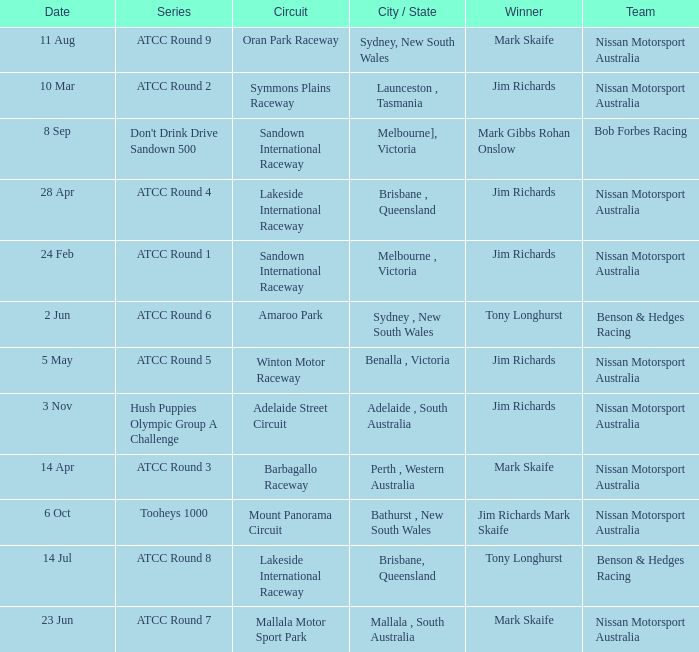Parse the full table. {'header': ['Date', 'Series', 'Circuit', 'City / State', 'Winner', 'Team'], 'rows': [['11 Aug', 'ATCC Round 9', 'Oran Park Raceway', 'Sydney, New South Wales', 'Mark Skaife', 'Nissan Motorsport Australia'], ['10 Mar', 'ATCC Round 2', 'Symmons Plains Raceway', 'Launceston , Tasmania', 'Jim Richards', 'Nissan Motorsport Australia'], ['8 Sep', "Don't Drink Drive Sandown 500", 'Sandown International Raceway', 'Melbourne], Victoria', 'Mark Gibbs Rohan Onslow', 'Bob Forbes Racing'], ['28 Apr', 'ATCC Round 4', 'Lakeside International Raceway', 'Brisbane , Queensland', 'Jim Richards', 'Nissan Motorsport Australia'], ['24 Feb', 'ATCC Round 1', 'Sandown International Raceway', 'Melbourne , Victoria', 'Jim Richards', 'Nissan Motorsport Australia'], ['2 Jun', 'ATCC Round 6', 'Amaroo Park', 'Sydney , New South Wales', 'Tony Longhurst', 'Benson & Hedges Racing'], ['5 May', 'ATCC Round 5', 'Winton Motor Raceway', 'Benalla , Victoria', 'Jim Richards', 'Nissan Motorsport Australia'], ['3 Nov', 'Hush Puppies Olympic Group A Challenge', 'Adelaide Street Circuit', 'Adelaide , South Australia', 'Jim Richards', 'Nissan Motorsport Australia'], ['14 Apr', 'ATCC Round 3', 'Barbagallo Raceway', 'Perth , Western Australia', 'Mark Skaife', 'Nissan Motorsport Australia'], ['6 Oct', 'Tooheys 1000', 'Mount Panorama Circuit', 'Bathurst , New South Wales', 'Jim Richards Mark Skaife', 'Nissan Motorsport Australia'], ['14 Jul', 'ATCC Round 8', 'Lakeside International Raceway', 'Brisbane, Queensland', 'Tony Longhurst', 'Benson & Hedges Racing'], ['23 Jun', 'ATCC Round 7', 'Mallala Motor Sport Park', 'Mallala , South Australia', 'Mark Skaife', 'Nissan Motorsport Australia']]} Who is the Winner of the Nissan Motorsport Australia Team at the Oran Park Raceway? Mark Skaife. 